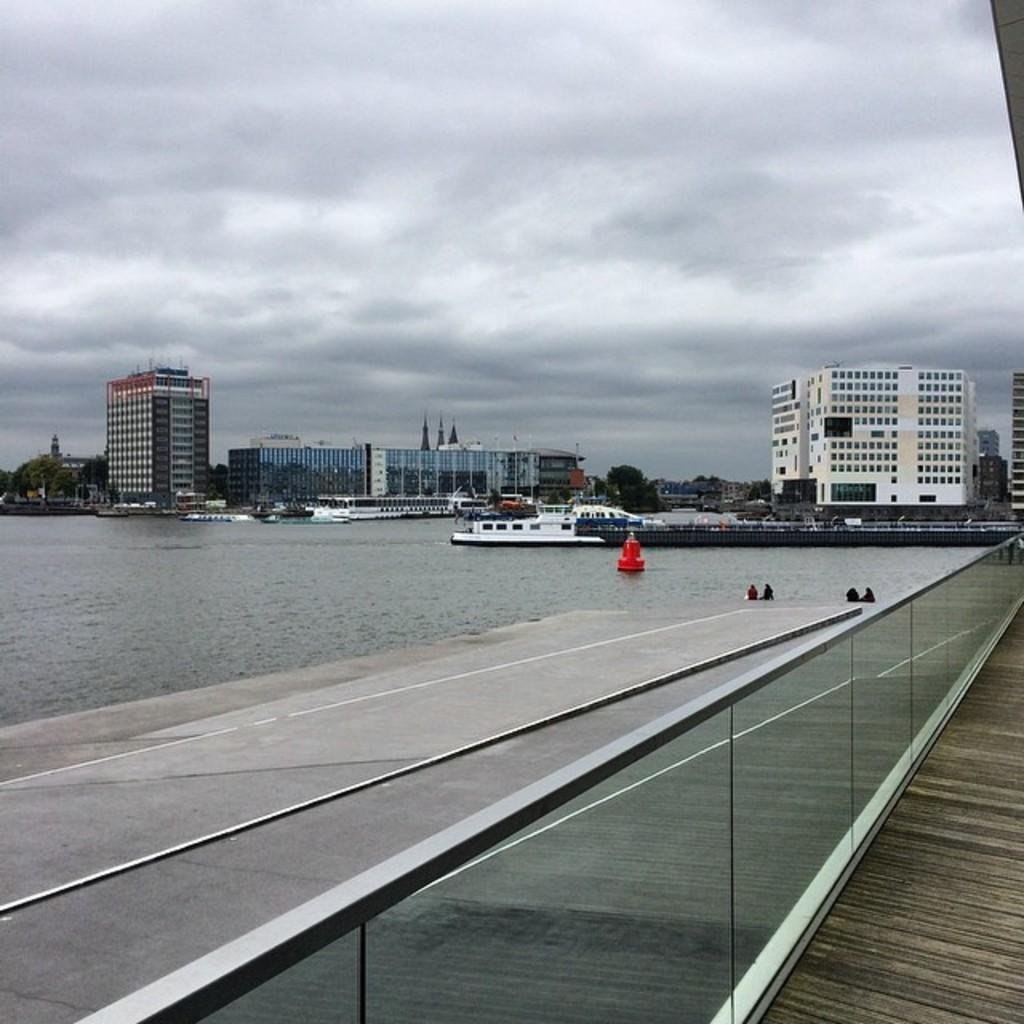What is in the water in the image? There are boats in the water in the image. What type of structure is present in the image? There is a glass wall in the image. What can be seen in the background of the image? There are buildings in the background of the image. What color are the buildings in the image? The buildings are white in color. What is the color of the sky in the image? The sky is white in color. How many feet are used to measure the length of the boats in the image? There is no mention of measuring the boats in the image, and feet are not a relevant unit of measurement for this context. Can you see a nest in the image? There is no nest present in the image. 